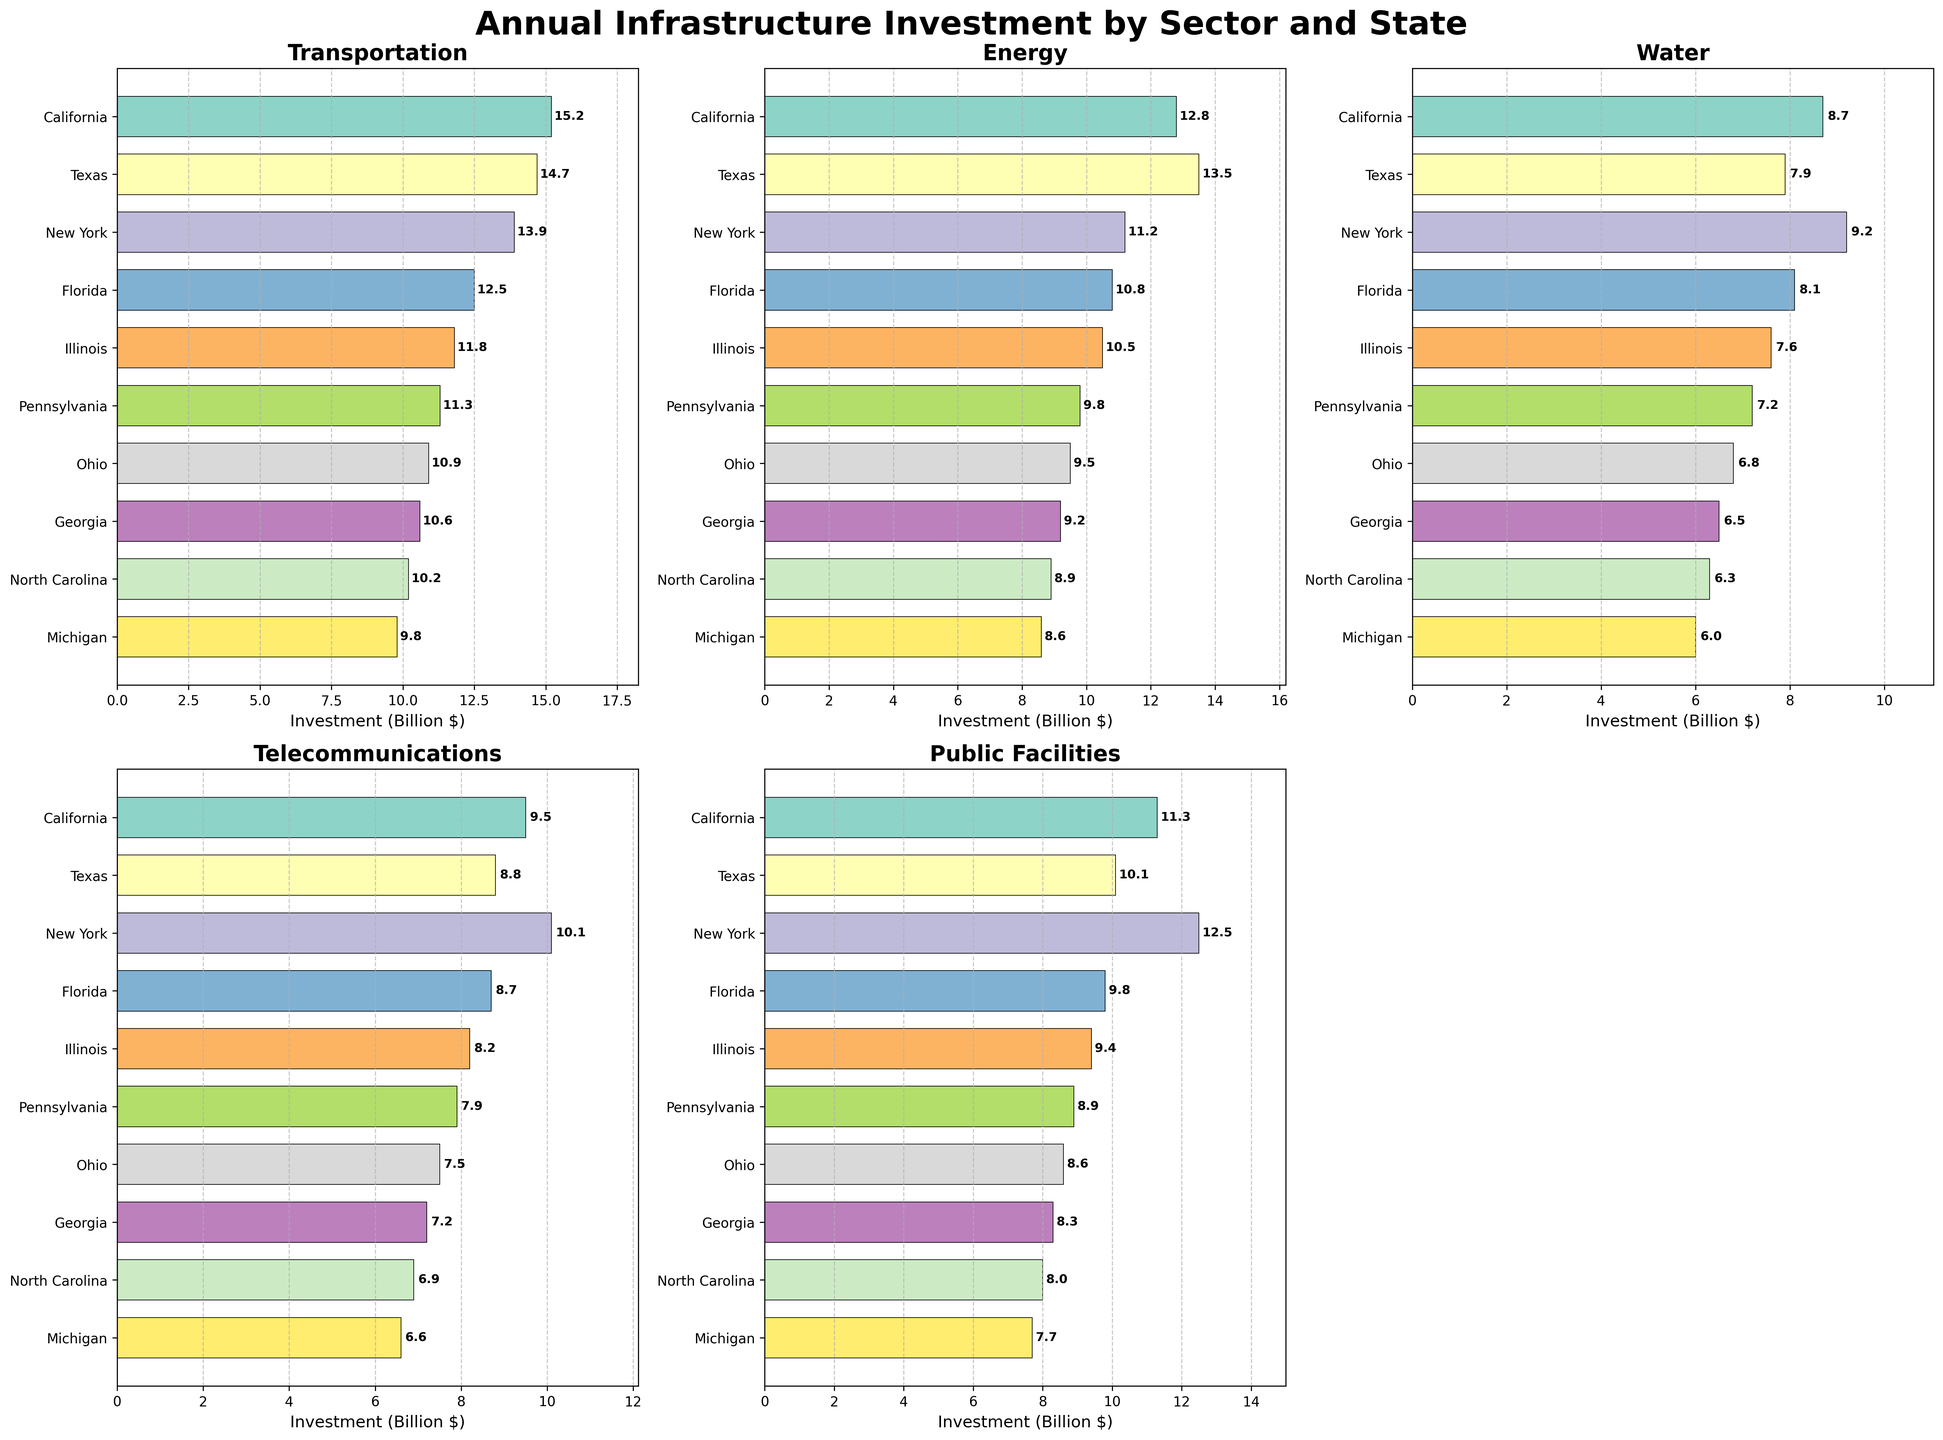Which state has the highest investment in Transportation? By observing the bar plot for Transportation, the state with the longest bar represents the highest investment, which is California with 15.2 billion dollars.
Answer: California Which sector has the lowest investment in Illinois? Checking all the bar plots for Illinois, the shortest bar is in the Water sector, with an investment of 7.6 billion dollars.
Answer: Water What is the total investment in Public Facilities across all states? Adding the values for Public Facilities across all the states gives: 11.3 + 10.1 + 12.5 + 9.8 + 9.4 + 8.9 + 8.6 + 8.3 + 8.0 + 7.7 = 94.6 billion dollars.
Answer: 94.6 Which state has a higher investment in Water: Texas or New York? Comparing the Water investments in the two states from their respective bar plots, Texas has 7.9 billion dollars, while New York has 9.2 billion dollars. New York has a higher investment.
Answer: New York Which sector has the most variation in investments across the states? By visually comparing the range and lengths of the bars across all sectors, the Energy sector appears to have the most variation, ranging from 13.5 billion dollars in Texas to 8.6 billion dollars in Michigan.
Answer: Energy Is the investment in Telecommunications higher in Pennsylvania or in Georgia? Comparing the Telecommunications bars for Pennsylvania (7.9 billion dollars) and Georgia (7.2 billion dollars), Pennsylvania has a higher investment.
Answer: Pennsylvania What is the average investment in Transportation across all states? Summing up the values for Transportation: 15.2 + 14.7 + 13.9 + 12.5 + 11.8 + 11.3 + 10.9 + 10.6 + 10.2 + 9.8 = 121.9; dividing by the number of states, 10: 121.9 / 10 = 12.19 billion dollars.
Answer: 12.19 Which state has an equal investment in both Transportation and Public Facilities? By looking at the bar plots, all states have different investment values for Transportation and Public Facilities, so no state has equal investments in both sectors.
Answer: None What is the rank of Ohio in terms of Energy investment among the states? Ordering states by their Energy investment values: Texas (13.5), California (12.8), New York (11.2), Florida (10.8), Illinois (10.5), Pennsylvania (9.8), Ohio (9.5), Georgia (9.2), North Carolina (8.9), Michigan (8.6), Ohio ranks 7th.
Answer: 7 What is the difference in investment between the highest and lowest states in Telecommunications? The highest investment in Telecommunications is New York (10.1 billion dollars) and the lowest is Michigan (6.6 billion dollars). The difference is 10.1 - 6.6 = 3.5 billion dollars.
Answer: 3.5 